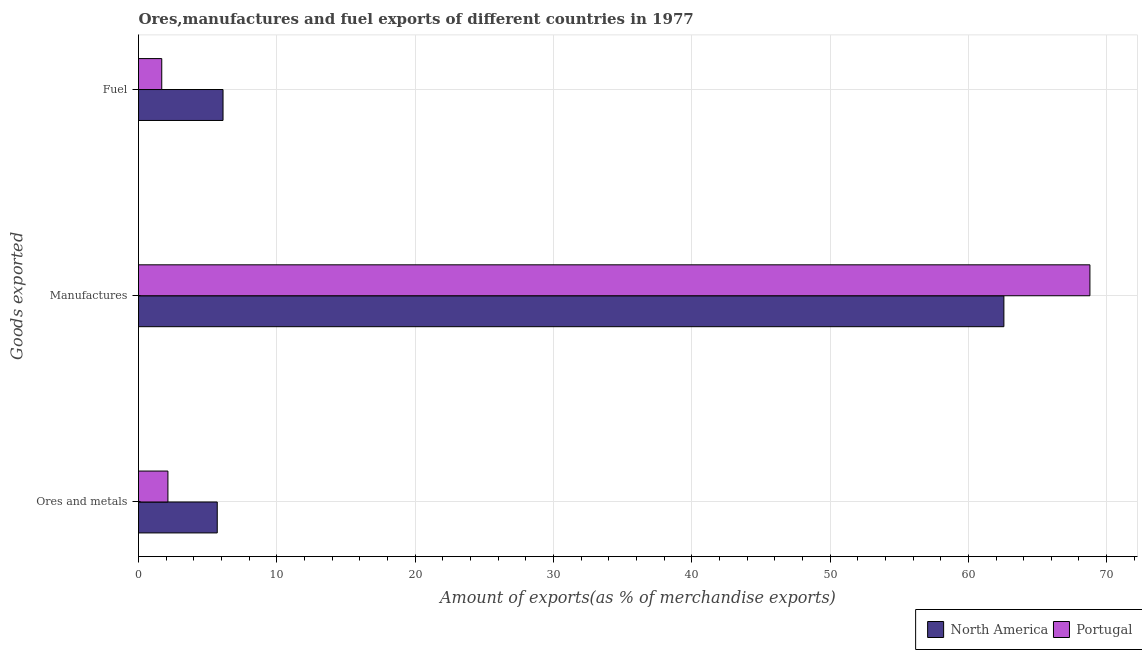How many groups of bars are there?
Provide a short and direct response. 3. How many bars are there on the 2nd tick from the top?
Offer a terse response. 2. How many bars are there on the 2nd tick from the bottom?
Your response must be concise. 2. What is the label of the 1st group of bars from the top?
Make the answer very short. Fuel. What is the percentage of fuel exports in Portugal?
Make the answer very short. 1.68. Across all countries, what is the maximum percentage of manufactures exports?
Your response must be concise. 68.79. Across all countries, what is the minimum percentage of manufactures exports?
Your answer should be compact. 62.57. What is the total percentage of fuel exports in the graph?
Provide a succinct answer. 7.79. What is the difference between the percentage of ores and metals exports in Portugal and that in North America?
Offer a terse response. -3.57. What is the difference between the percentage of manufactures exports in Portugal and the percentage of fuel exports in North America?
Offer a very short reply. 62.68. What is the average percentage of manufactures exports per country?
Your response must be concise. 65.68. What is the difference between the percentage of fuel exports and percentage of manufactures exports in Portugal?
Ensure brevity in your answer.  -67.11. What is the ratio of the percentage of fuel exports in Portugal to that in North America?
Provide a succinct answer. 0.27. Is the difference between the percentage of fuel exports in North America and Portugal greater than the difference between the percentage of ores and metals exports in North America and Portugal?
Ensure brevity in your answer.  Yes. What is the difference between the highest and the second highest percentage of ores and metals exports?
Offer a terse response. 3.57. What is the difference between the highest and the lowest percentage of manufactures exports?
Your answer should be compact. 6.22. What does the 1st bar from the top in Manufactures represents?
Make the answer very short. Portugal. Is it the case that in every country, the sum of the percentage of ores and metals exports and percentage of manufactures exports is greater than the percentage of fuel exports?
Give a very brief answer. Yes. How many bars are there?
Offer a terse response. 6. What is the difference between two consecutive major ticks on the X-axis?
Provide a short and direct response. 10. Does the graph contain grids?
Ensure brevity in your answer.  Yes. Where does the legend appear in the graph?
Provide a short and direct response. Bottom right. How are the legend labels stacked?
Give a very brief answer. Horizontal. What is the title of the graph?
Ensure brevity in your answer.  Ores,manufactures and fuel exports of different countries in 1977. Does "Russian Federation" appear as one of the legend labels in the graph?
Make the answer very short. No. What is the label or title of the X-axis?
Offer a very short reply. Amount of exports(as % of merchandise exports). What is the label or title of the Y-axis?
Keep it short and to the point. Goods exported. What is the Amount of exports(as % of merchandise exports) in North America in Ores and metals?
Provide a succinct answer. 5.69. What is the Amount of exports(as % of merchandise exports) in Portugal in Ores and metals?
Keep it short and to the point. 2.13. What is the Amount of exports(as % of merchandise exports) in North America in Manufactures?
Provide a succinct answer. 62.57. What is the Amount of exports(as % of merchandise exports) of Portugal in Manufactures?
Your response must be concise. 68.79. What is the Amount of exports(as % of merchandise exports) in North America in Fuel?
Your answer should be very brief. 6.11. What is the Amount of exports(as % of merchandise exports) of Portugal in Fuel?
Your response must be concise. 1.68. Across all Goods exported, what is the maximum Amount of exports(as % of merchandise exports) of North America?
Ensure brevity in your answer.  62.57. Across all Goods exported, what is the maximum Amount of exports(as % of merchandise exports) of Portugal?
Ensure brevity in your answer.  68.79. Across all Goods exported, what is the minimum Amount of exports(as % of merchandise exports) of North America?
Offer a very short reply. 5.69. Across all Goods exported, what is the minimum Amount of exports(as % of merchandise exports) of Portugal?
Your answer should be very brief. 1.68. What is the total Amount of exports(as % of merchandise exports) of North America in the graph?
Keep it short and to the point. 74.37. What is the total Amount of exports(as % of merchandise exports) in Portugal in the graph?
Give a very brief answer. 72.6. What is the difference between the Amount of exports(as % of merchandise exports) in North America in Ores and metals and that in Manufactures?
Provide a short and direct response. -56.88. What is the difference between the Amount of exports(as % of merchandise exports) in Portugal in Ores and metals and that in Manufactures?
Provide a short and direct response. -66.66. What is the difference between the Amount of exports(as % of merchandise exports) of North America in Ores and metals and that in Fuel?
Ensure brevity in your answer.  -0.42. What is the difference between the Amount of exports(as % of merchandise exports) in Portugal in Ores and metals and that in Fuel?
Provide a succinct answer. 0.45. What is the difference between the Amount of exports(as % of merchandise exports) in North America in Manufactures and that in Fuel?
Give a very brief answer. 56.46. What is the difference between the Amount of exports(as % of merchandise exports) of Portugal in Manufactures and that in Fuel?
Give a very brief answer. 67.11. What is the difference between the Amount of exports(as % of merchandise exports) in North America in Ores and metals and the Amount of exports(as % of merchandise exports) in Portugal in Manufactures?
Offer a terse response. -63.1. What is the difference between the Amount of exports(as % of merchandise exports) in North America in Ores and metals and the Amount of exports(as % of merchandise exports) in Portugal in Fuel?
Ensure brevity in your answer.  4.01. What is the difference between the Amount of exports(as % of merchandise exports) of North America in Manufactures and the Amount of exports(as % of merchandise exports) of Portugal in Fuel?
Give a very brief answer. 60.89. What is the average Amount of exports(as % of merchandise exports) in North America per Goods exported?
Offer a terse response. 24.79. What is the average Amount of exports(as % of merchandise exports) of Portugal per Goods exported?
Provide a succinct answer. 24.2. What is the difference between the Amount of exports(as % of merchandise exports) in North America and Amount of exports(as % of merchandise exports) in Portugal in Ores and metals?
Keep it short and to the point. 3.57. What is the difference between the Amount of exports(as % of merchandise exports) of North America and Amount of exports(as % of merchandise exports) of Portugal in Manufactures?
Your answer should be compact. -6.22. What is the difference between the Amount of exports(as % of merchandise exports) in North America and Amount of exports(as % of merchandise exports) in Portugal in Fuel?
Provide a short and direct response. 4.43. What is the ratio of the Amount of exports(as % of merchandise exports) of North America in Ores and metals to that in Manufactures?
Provide a short and direct response. 0.09. What is the ratio of the Amount of exports(as % of merchandise exports) in Portugal in Ores and metals to that in Manufactures?
Offer a terse response. 0.03. What is the ratio of the Amount of exports(as % of merchandise exports) of North America in Ores and metals to that in Fuel?
Your answer should be compact. 0.93. What is the ratio of the Amount of exports(as % of merchandise exports) of Portugal in Ores and metals to that in Fuel?
Your answer should be compact. 1.27. What is the ratio of the Amount of exports(as % of merchandise exports) of North America in Manufactures to that in Fuel?
Ensure brevity in your answer.  10.24. What is the ratio of the Amount of exports(as % of merchandise exports) of Portugal in Manufactures to that in Fuel?
Give a very brief answer. 40.94. What is the difference between the highest and the second highest Amount of exports(as % of merchandise exports) of North America?
Keep it short and to the point. 56.46. What is the difference between the highest and the second highest Amount of exports(as % of merchandise exports) of Portugal?
Offer a very short reply. 66.66. What is the difference between the highest and the lowest Amount of exports(as % of merchandise exports) of North America?
Make the answer very short. 56.88. What is the difference between the highest and the lowest Amount of exports(as % of merchandise exports) of Portugal?
Offer a very short reply. 67.11. 